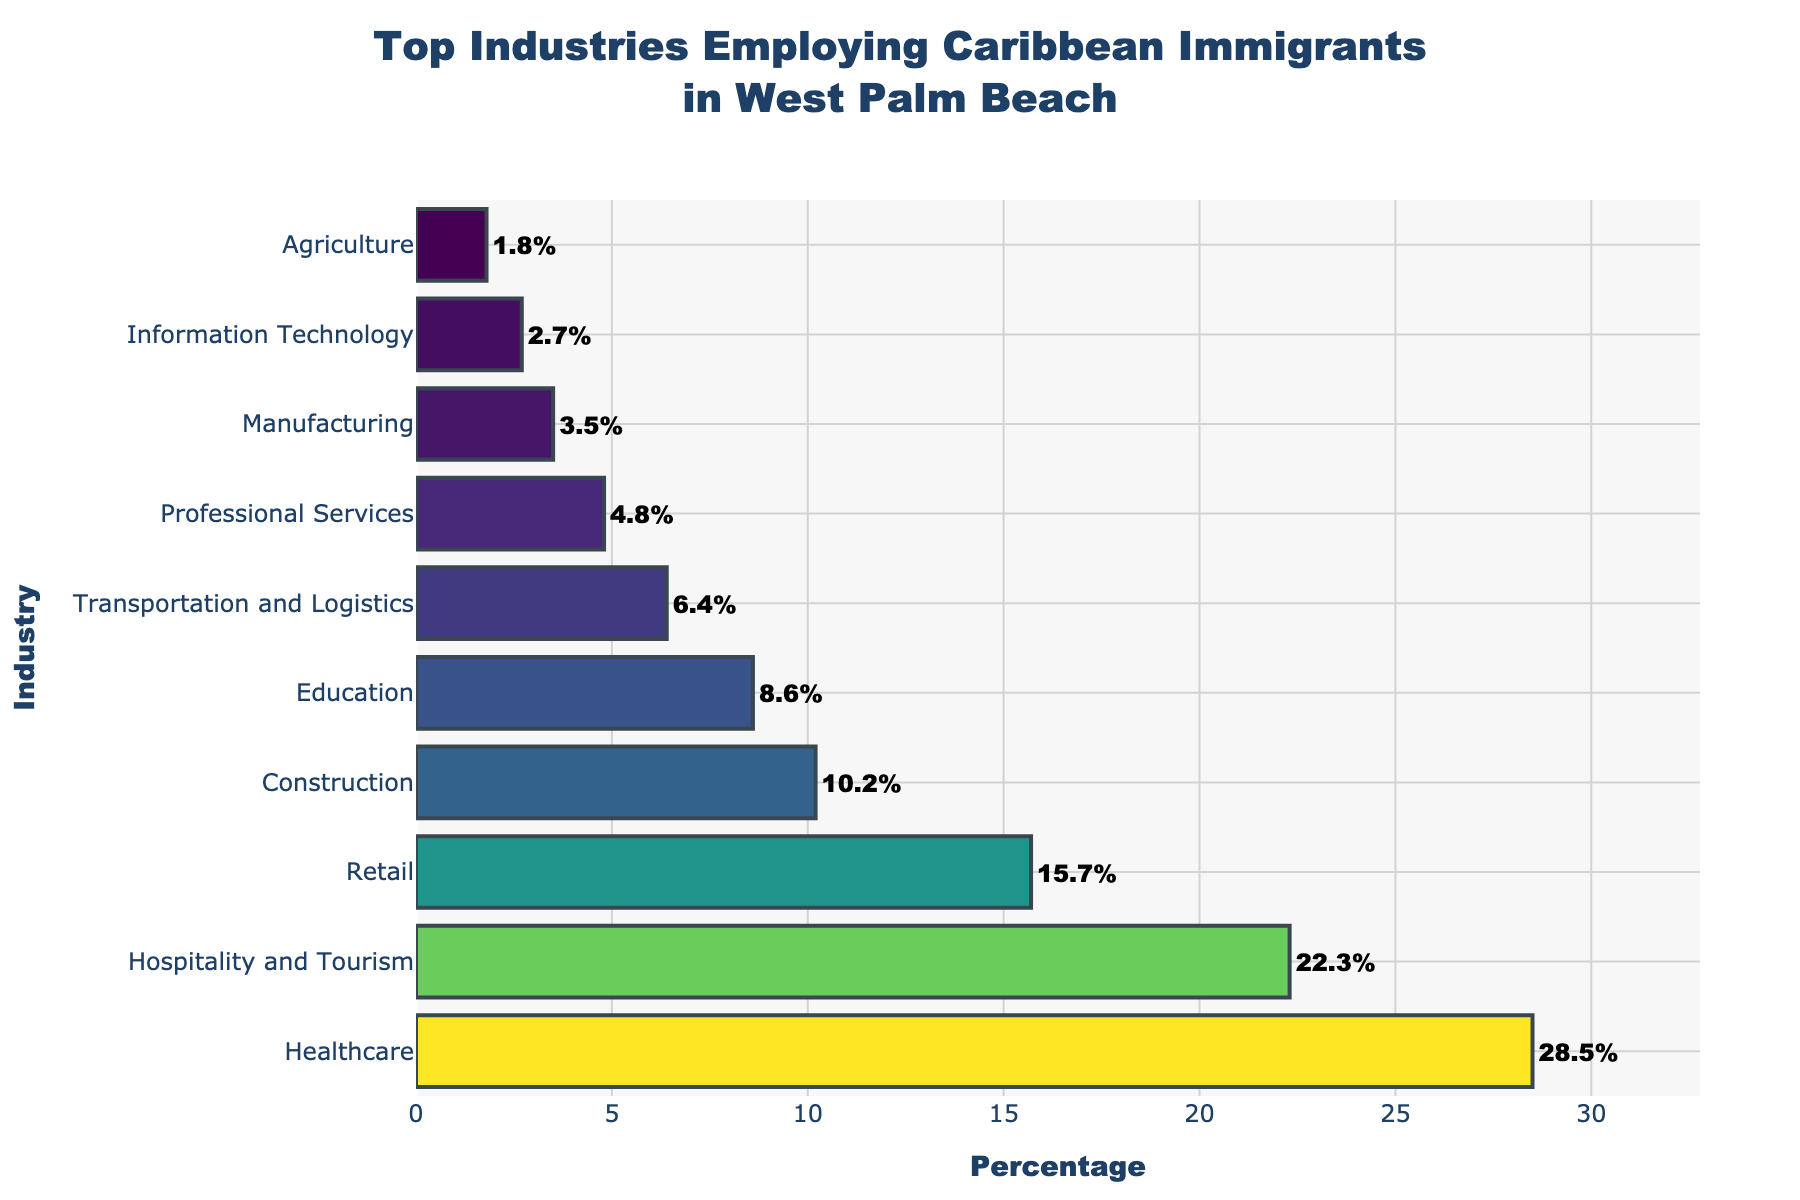Which industry employs the highest percentage of Caribbean immigrants? The figure shows a horizontal bar chart with percentages next to each industry. The industry with the longest bar represent the highest percentage
Answer: Healthcare What is the difference in the percentage of Caribbean immigrants employed in Healthcare compared to those in Manufacturing? The percentage of Caribbean immigrants in Healthcare is 28.5%, while in Manufacturing it's 3.5%. The difference is found by subtracting the smaller percentage from the larger one, i.e., 28.5% - 3.5% = 25%
Answer: 25% Is the percentage of Caribbean immigrants employed in Education greater than that in Transportation and Logistics? Compare the bars for Education and Transportation. Education has a percentage of 8.6%, while Transportation and Logistics have 6.4%. Since 8.6% is greater than 6.4%, the answer is yes
Answer: Yes What’s the total percentage of Caribbean immigrants employed in the top three industries? Healthcare, Hospitality and Tourism, and Retail are the top three industries. Summing their percentages: 28.5% + 22.3% + 15.7% = 66.5%
Answer: 66.5% Which industry employs fewer Caribbean immigrants: Agriculture or Professional Services? The figure shows that Agriculture has 1.8% while Professional Services have 4.8%. Since 1.8% is less than 4.8%, Agriculture employs fewer Caribbean immigrants
Answer: Agriculture How much more significant is the percentage of Caribbean immigrants in Healthcare compared to Retail? Healthcare has 28.5% and Retail has 15.7%. Subtract Retail's percentage from Healthcare's: 28.5% - 15.7% = 12.8%
Answer: 12.8% Which industries have employment percentages below 5%? From the figure, the bars for Professional Services, Manufacturing, Information Technology, and Agriculture are below 5%, with respective percentages of 4.8%, 3.5%, 2.7%, and 1.8%
Answer: Professional Services, Manufacturing, Information Technology, Agriculture What is the combined percentage of Caribbean immigrants working in Retail and Construction? Add the percentages of Retail and Construction: 15.7% + 10.2% = 25.9%
Answer: 25.9% Are there more Caribbean immigrants working in Hospitality and Tourism or in Education? Compare the lengths of the bars for Hospitality and Tourism (22.3%) and Education (8.6%). Hospitality and Tourism has a larger percentage, meaning more Caribbean immigrants work there
Answer: Hospitality and Tourism 